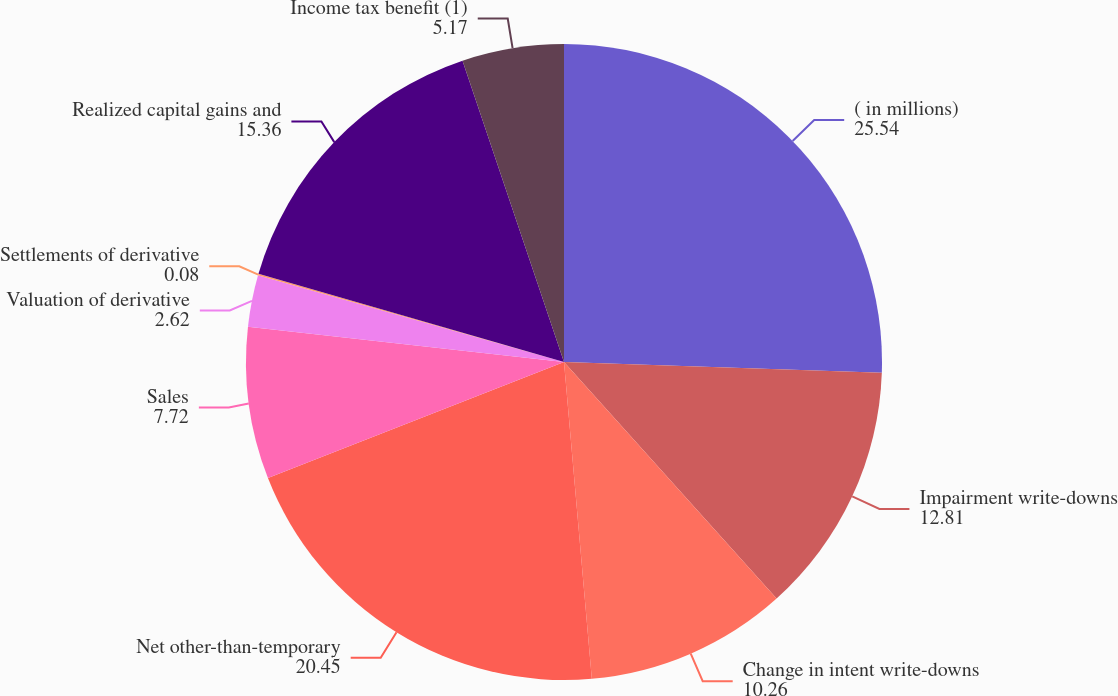Convert chart to OTSL. <chart><loc_0><loc_0><loc_500><loc_500><pie_chart><fcel>( in millions)<fcel>Impairment write-downs<fcel>Change in intent write-downs<fcel>Net other-than-temporary<fcel>Sales<fcel>Valuation of derivative<fcel>Settlements of derivative<fcel>Realized capital gains and<fcel>Income tax benefit (1)<nl><fcel>25.54%<fcel>12.81%<fcel>10.26%<fcel>20.45%<fcel>7.72%<fcel>2.62%<fcel>0.08%<fcel>15.36%<fcel>5.17%<nl></chart> 